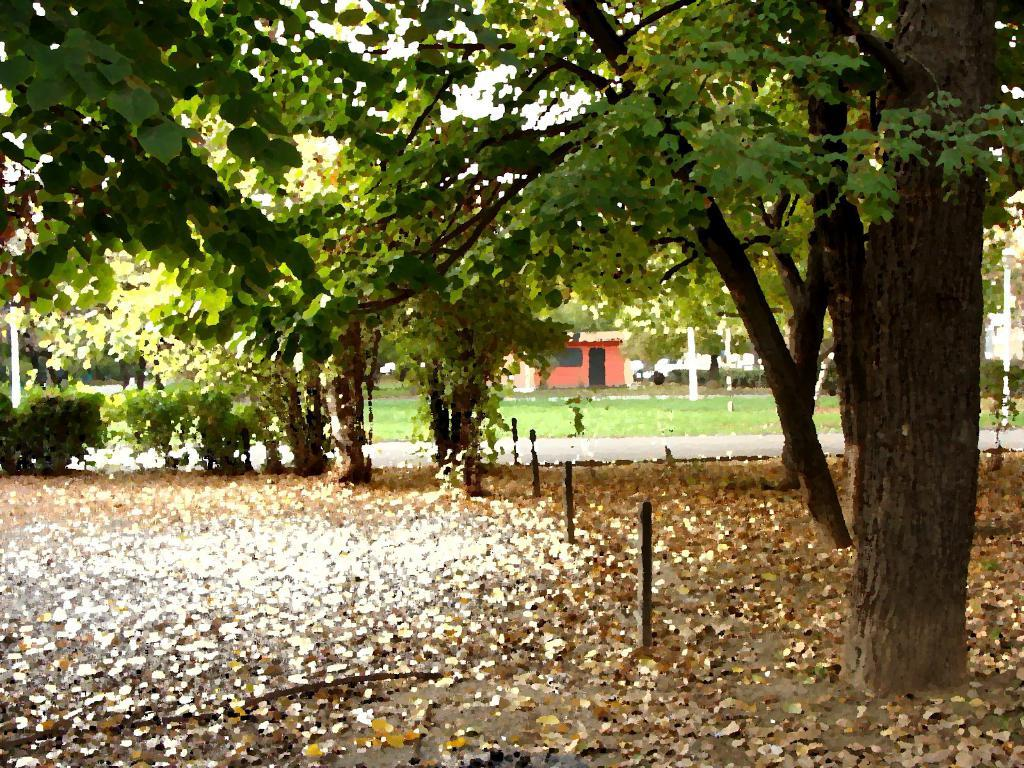What is located in the middle of the image? There are trees in the middle of the image. What can be seen at the bottom of the image? Dry leaves and small poles are visible at the bottom of the image. What is present in the background of the image? There are poles and a building with a red color in the background of the image. How many loaves of bread are resting on the poles in the image? There are no loaves of bread present in the image. Can you see any ducks swimming in the dry leaves at the bottom of the image? There are no ducks or water visible in the image, only dry leaves and small poles. 